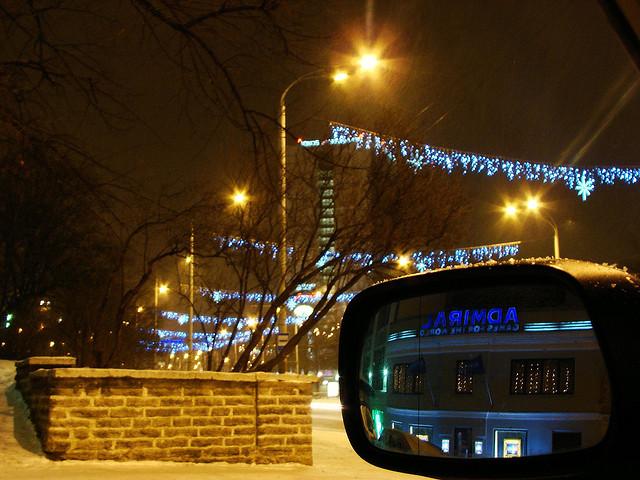What season does it appear to be?
Quick response, please. Winter. Is it night time?
Give a very brief answer. Yes. What color the strings of bright lights?
Give a very brief answer. Blue. 